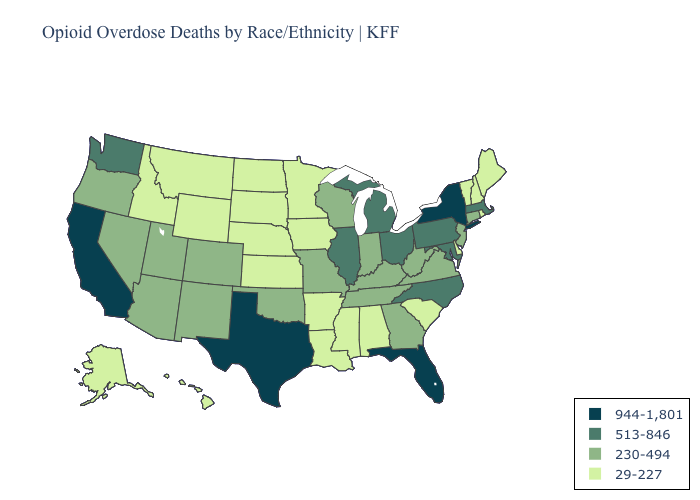Does Kentucky have the same value as North Dakota?
Quick response, please. No. What is the value of New York?
Give a very brief answer. 944-1,801. Does Georgia have the same value as North Carolina?
Give a very brief answer. No. What is the lowest value in states that border Washington?
Short answer required. 29-227. What is the value of Alabama?
Short answer required. 29-227. What is the value of Maine?
Answer briefly. 29-227. Does California have the highest value in the USA?
Short answer required. Yes. Name the states that have a value in the range 944-1,801?
Quick response, please. California, Florida, New York, Texas. Does the map have missing data?
Write a very short answer. No. Among the states that border Idaho , which have the highest value?
Answer briefly. Washington. What is the highest value in the Northeast ?
Keep it brief. 944-1,801. Does Connecticut have a higher value than Colorado?
Concise answer only. No. Does Kansas have the lowest value in the USA?
Answer briefly. Yes. Name the states that have a value in the range 230-494?
Short answer required. Arizona, Colorado, Connecticut, Georgia, Indiana, Kentucky, Missouri, Nevada, New Jersey, New Mexico, Oklahoma, Oregon, Tennessee, Utah, Virginia, West Virginia, Wisconsin. What is the value of Massachusetts?
Be succinct. 513-846. 